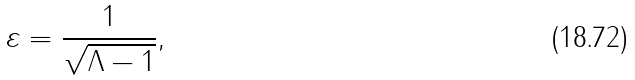<formula> <loc_0><loc_0><loc_500><loc_500>\varepsilon = \frac { 1 } { \sqrt { \Lambda - 1 } } ,</formula> 